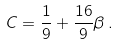<formula> <loc_0><loc_0><loc_500><loc_500>C = \frac { 1 } { 9 } + \frac { 1 6 } { 9 } \beta \, .</formula> 